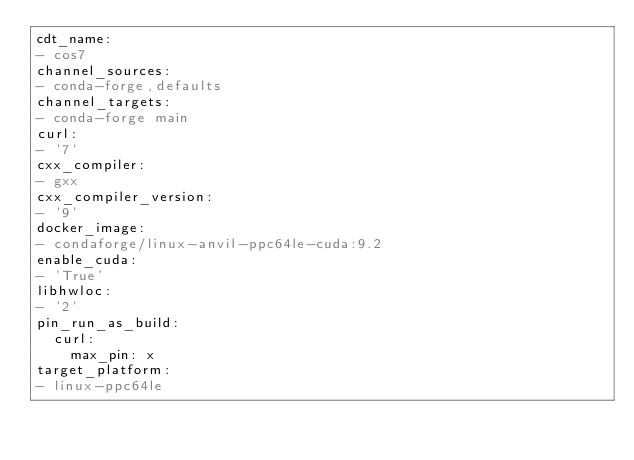Convert code to text. <code><loc_0><loc_0><loc_500><loc_500><_YAML_>cdt_name:
- cos7
channel_sources:
- conda-forge,defaults
channel_targets:
- conda-forge main
curl:
- '7'
cxx_compiler:
- gxx
cxx_compiler_version:
- '9'
docker_image:
- condaforge/linux-anvil-ppc64le-cuda:9.2
enable_cuda:
- 'True'
libhwloc:
- '2'
pin_run_as_build:
  curl:
    max_pin: x
target_platform:
- linux-ppc64le
</code> 